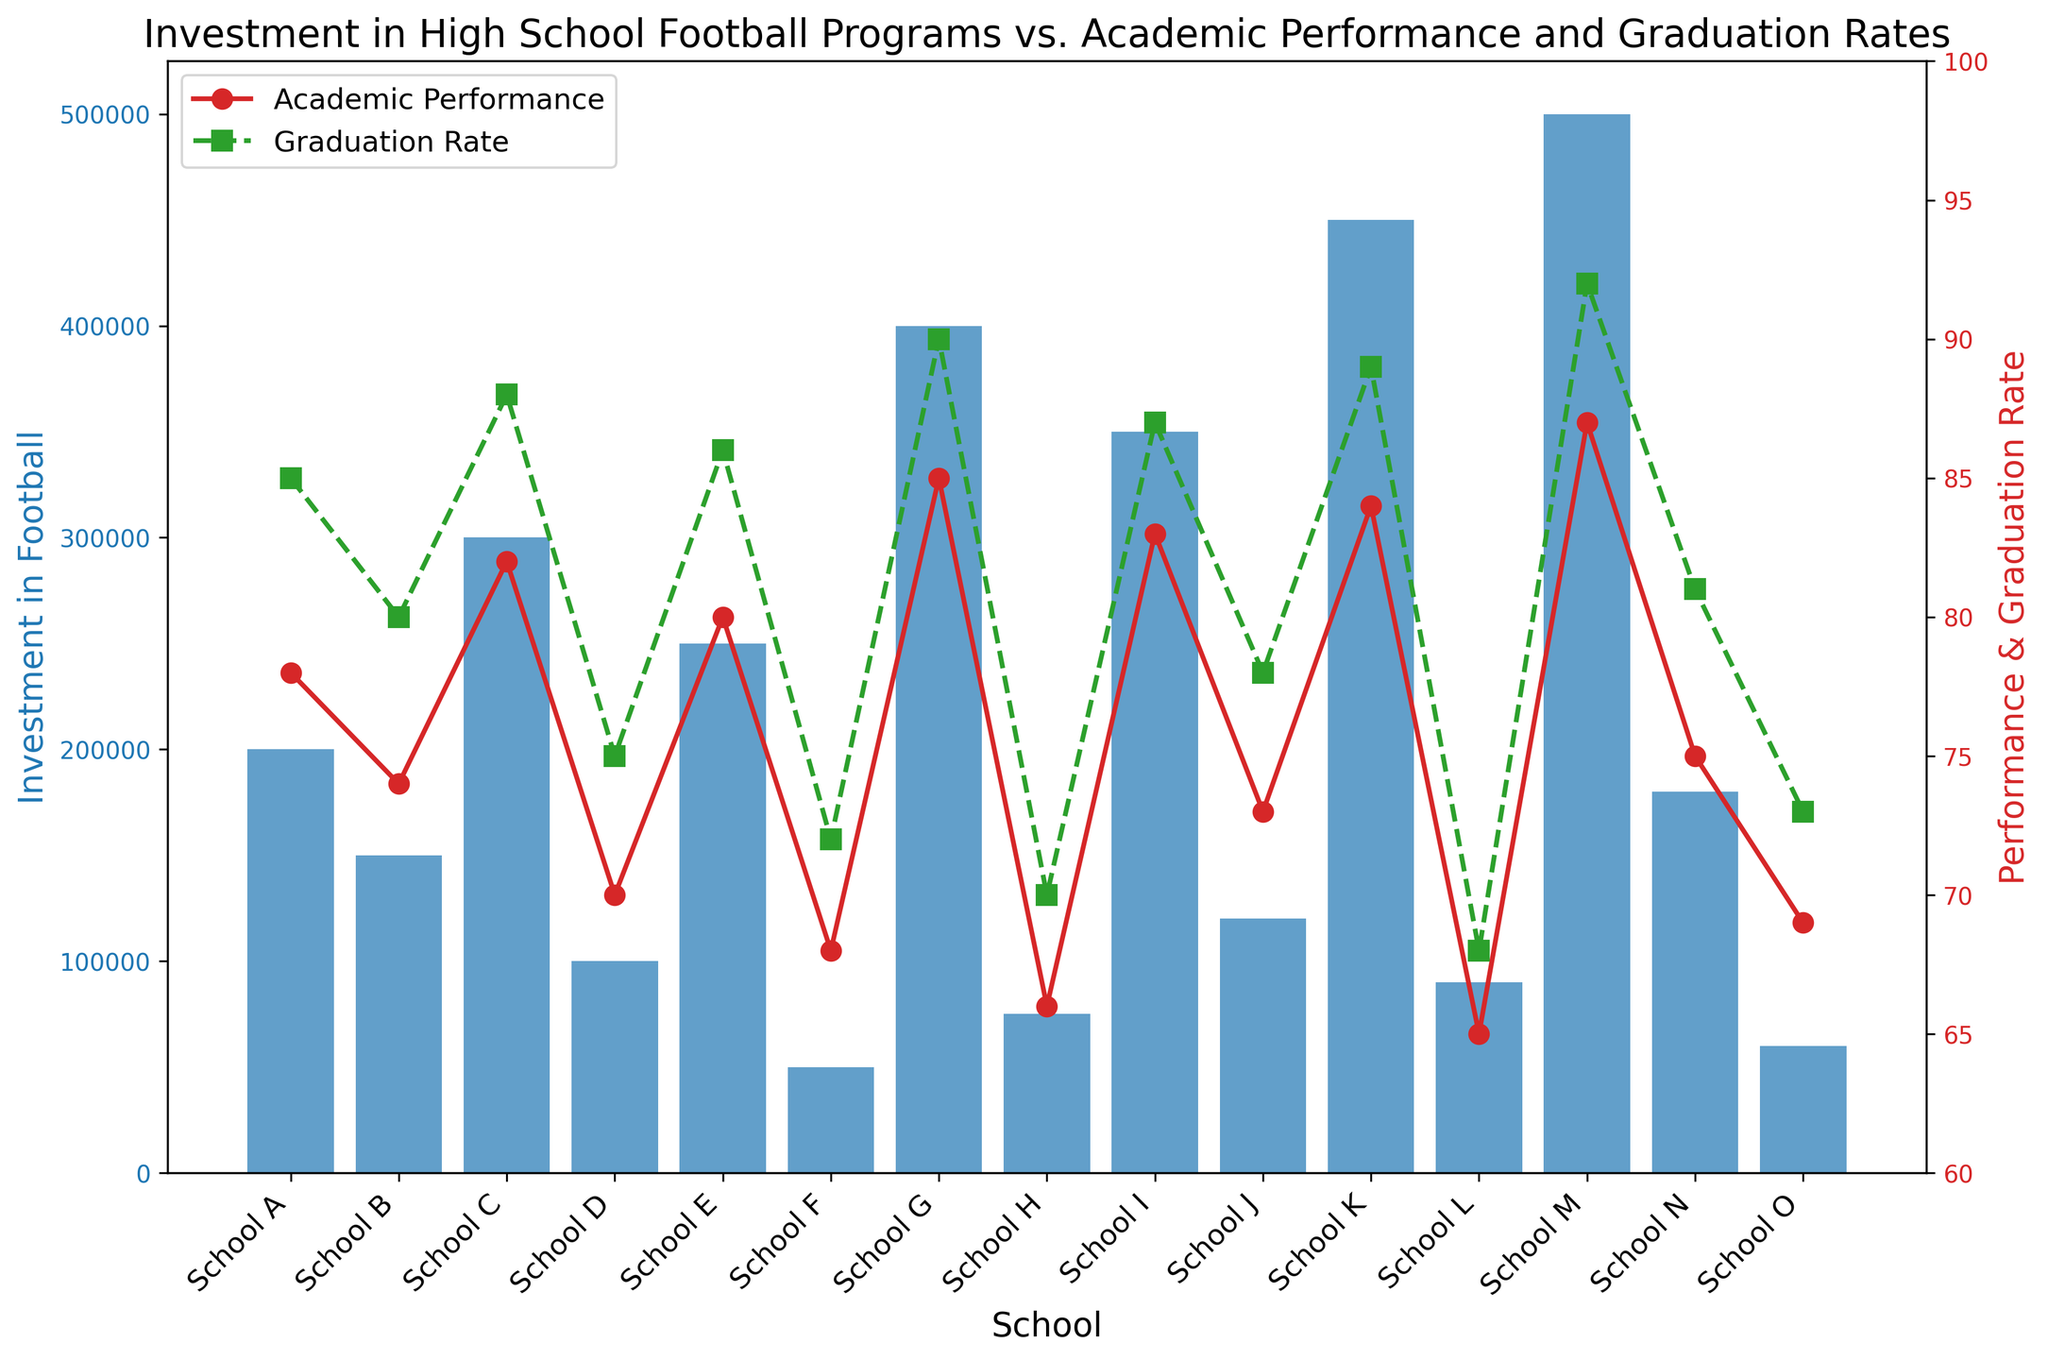School M has the highest investment in football programs. Which school has the lowest investment, and what is the amount? From the plot, School O has the shortest bar, indicating the lowest investment in football. You can see the investment value is around 60,000 units, based on the y-axis.
Answer: School O, 60,000 How does School G’s academic performance compare to its graduation rate? For School G, the red line (academic performance) marker is slightly below the green dashed line (graduation rate) marker. This shows the academic performance is slightly lower than the graduation rate.
Answer: Academic performance is lower than graduation rate Between Schools B and N, which one has a higher graduation rate, and by how much? School B’s graduation rate (green marker) is at 80, and School N’s graduation rate is at 81. Comparing both, School N’s graduation rate is higher by 1 unit.
Answer: School N, by 1 unit Which school has both the highest academic performance and the highest graduation rate? By looking at the plot, School M’s red line marker is the highest at 87, and its green dashed line marker is also the highest at 92, indicating School M has the highest in both metrics.
Answer: School M Calculate the average academic performance for Schools A, B, C, and D. Sum the academic performance values for Schools A, B, C, and D: 78 + 74 + 82 + 70 = 304. There are 4 schools, so the average is 304 / 4.
Answer: 76 What is the difference in investment between the highest and lowest-invested schools? The highest investment is for School M (500,000) and the lowest is School O (60,000). The difference is 500,000 - 60,000.
Answer: 440,000 How does the investment in football for the top three performing schools compare? The top three performing schools based on academic performance are Schools M (87), G (85), and K (84). Their football investments are 500,000, 400,000, and 450,000 respectively.
Answer: School M: 500,000, School G: 400,000, School K: 450,000 What is the total investment in football across all schools? Sum the values for the investment in football from all schools: 200000 + 150000 + 300000 + 100000 + 250000 + 50000 + 400000 + 75000 + 350000 + 120000 + 450000 + 90000 + 500000 + 180000 + 60000 = 3185000
Answer: 3,185,000 Which schools have an academic performance above 80 and what are their respective investments? The plot shows Schools C, E, G, I, K, and M with academic performances above 80. Their investments are 300000, 250000, 400000, 350000, 450000, and 500000 respectively.
Answer: Schools C, E, G, I, K, M and 300,000; 250,000; 400,000; 350,000; 450,000; 500,000 respectively Compare the graduation rates of School A and School F. School A’s green dashed line (graduation rate) marker is at 85, while School F’s is at 72. School A’s graduation rate is higher than School F’s by 13 units.
Answer: School A’s is higher by 13 units 